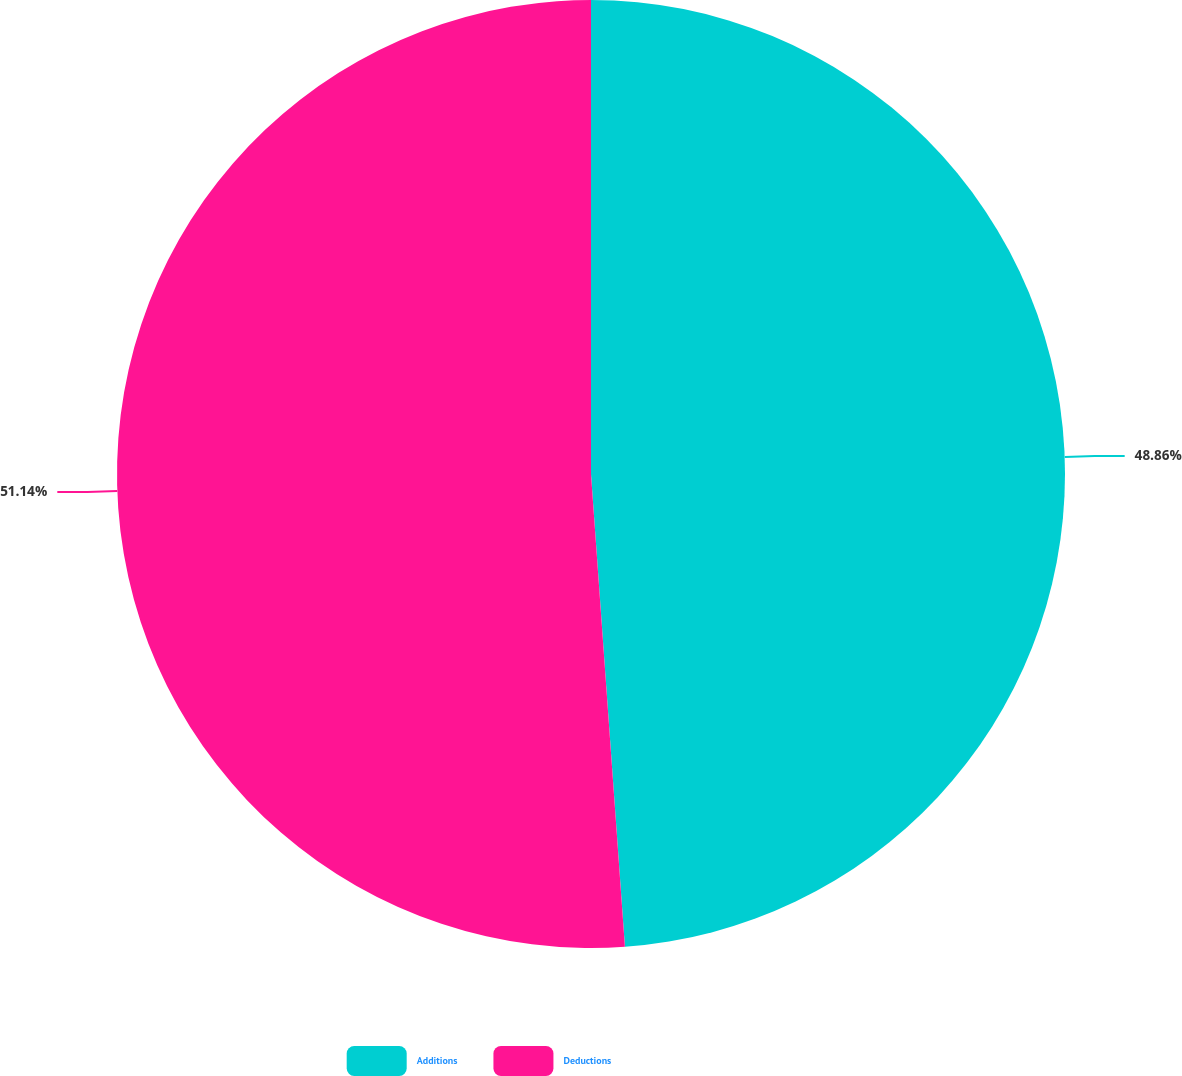Convert chart to OTSL. <chart><loc_0><loc_0><loc_500><loc_500><pie_chart><fcel>Additions<fcel>Deductions<nl><fcel>48.86%<fcel>51.14%<nl></chart> 